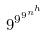<formula> <loc_0><loc_0><loc_500><loc_500>9 ^ { 9 ^ { 9 ^ { n ^ { h } } } }</formula> 